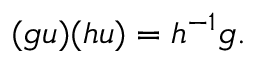Convert formula to latex. <formula><loc_0><loc_0><loc_500><loc_500>( g u ) ( h u ) = h ^ { - 1 } g .</formula> 